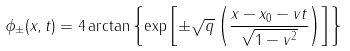Convert formula to latex. <formula><loc_0><loc_0><loc_500><loc_500>\phi _ { \pm } ( x , t ) = 4 \arctan \left \{ \exp \left [ \pm \sqrt { q } \left ( \frac { x - x _ { 0 } - v t } { \sqrt { 1 - v ^ { 2 } } } \right ) \right ] \right \}</formula> 